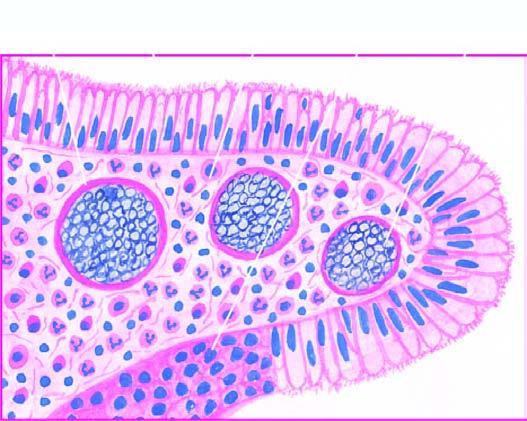re the spores present in sporangia as well as are intermingled in the inflammatory cell infiltrate?
Answer the question using a single word or phrase. Yes 